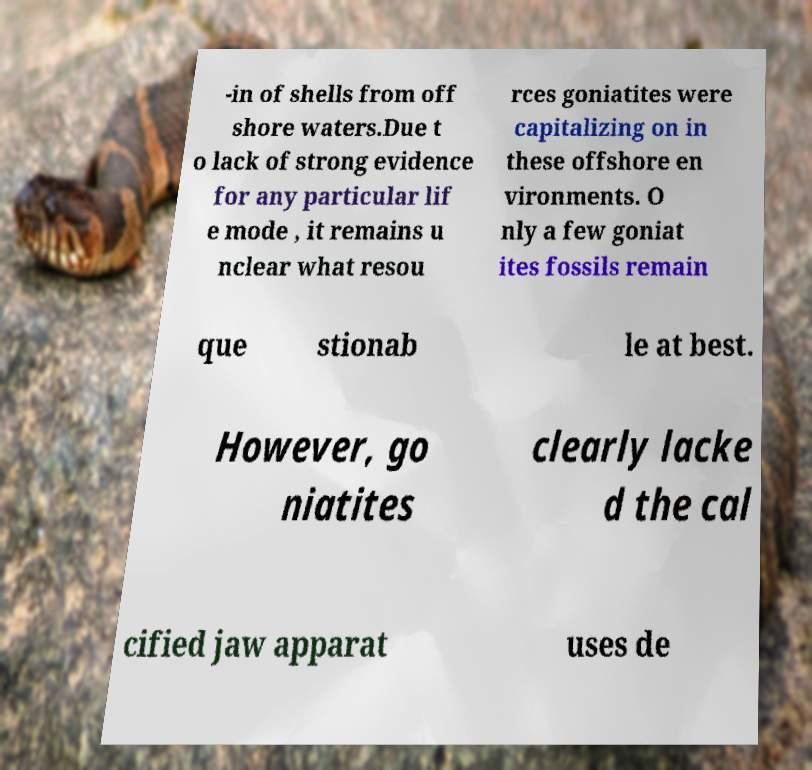There's text embedded in this image that I need extracted. Can you transcribe it verbatim? -in of shells from off shore waters.Due t o lack of strong evidence for any particular lif e mode , it remains u nclear what resou rces goniatites were capitalizing on in these offshore en vironments. O nly a few goniat ites fossils remain que stionab le at best. However, go niatites clearly lacke d the cal cified jaw apparat uses de 